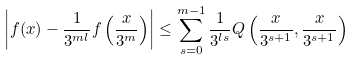Convert formula to latex. <formula><loc_0><loc_0><loc_500><loc_500>\left | f ( x ) - \frac { 1 } { 3 ^ { m l } } f \left ( \frac { x } { 3 ^ { m } } \right ) \right | \leq \sum _ { s = 0 } ^ { m - 1 } \frac { 1 } { 3 ^ { l s } } Q \left ( \frac { x } { 3 ^ { s + 1 } } , \frac { x } { 3 ^ { s + 1 } } \right )</formula> 